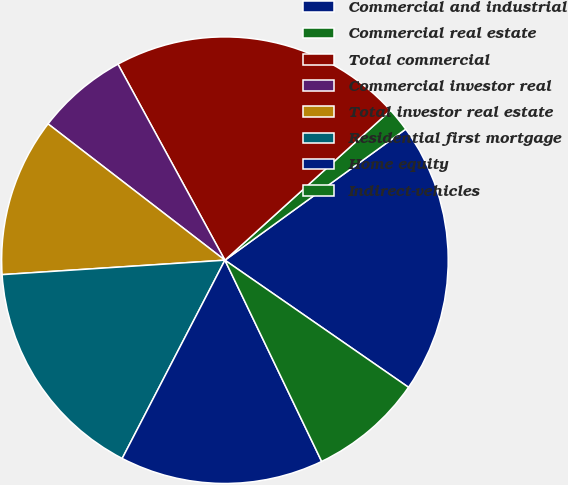Convert chart. <chart><loc_0><loc_0><loc_500><loc_500><pie_chart><fcel>Commercial and industrial<fcel>Commercial real estate<fcel>Total commercial<fcel>Commercial investor real<fcel>Total investor real estate<fcel>Residential first mortgage<fcel>Home equity<fcel>Indirect-vehicles<nl><fcel>19.62%<fcel>1.72%<fcel>21.25%<fcel>6.6%<fcel>11.48%<fcel>16.36%<fcel>14.74%<fcel>8.23%<nl></chart> 